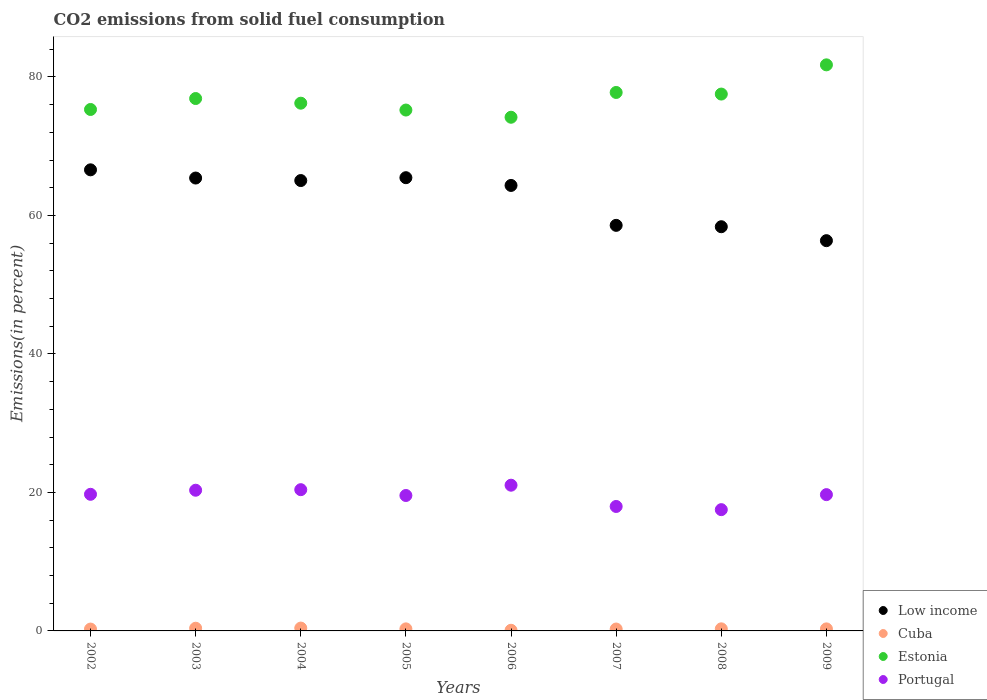Is the number of dotlines equal to the number of legend labels?
Your answer should be compact. Yes. What is the total CO2 emitted in Cuba in 2004?
Keep it short and to the point. 0.41. Across all years, what is the maximum total CO2 emitted in Cuba?
Your answer should be compact. 0.41. Across all years, what is the minimum total CO2 emitted in Cuba?
Provide a succinct answer. 0.09. What is the total total CO2 emitted in Low income in the graph?
Give a very brief answer. 500.1. What is the difference between the total CO2 emitted in Cuba in 2002 and that in 2007?
Your answer should be very brief. -0.01. What is the difference between the total CO2 emitted in Estonia in 2007 and the total CO2 emitted in Cuba in 2009?
Provide a succinct answer. 77.46. What is the average total CO2 emitted in Low income per year?
Your answer should be very brief. 62.51. In the year 2009, what is the difference between the total CO2 emitted in Low income and total CO2 emitted in Portugal?
Ensure brevity in your answer.  36.68. What is the ratio of the total CO2 emitted in Cuba in 2003 to that in 2009?
Your response must be concise. 1.32. What is the difference between the highest and the second highest total CO2 emitted in Estonia?
Your answer should be very brief. 3.99. What is the difference between the highest and the lowest total CO2 emitted in Cuba?
Keep it short and to the point. 0.32. In how many years, is the total CO2 emitted in Portugal greater than the average total CO2 emitted in Portugal taken over all years?
Your answer should be very brief. 6. Is the sum of the total CO2 emitted in Estonia in 2004 and 2008 greater than the maximum total CO2 emitted in Cuba across all years?
Give a very brief answer. Yes. Is it the case that in every year, the sum of the total CO2 emitted in Portugal and total CO2 emitted in Low income  is greater than the total CO2 emitted in Estonia?
Your response must be concise. No. How many years are there in the graph?
Your answer should be compact. 8. Are the values on the major ticks of Y-axis written in scientific E-notation?
Your answer should be compact. No. Does the graph contain grids?
Make the answer very short. No. Where does the legend appear in the graph?
Offer a very short reply. Bottom right. How many legend labels are there?
Provide a short and direct response. 4. What is the title of the graph?
Offer a terse response. CO2 emissions from solid fuel consumption. What is the label or title of the X-axis?
Your response must be concise. Years. What is the label or title of the Y-axis?
Provide a short and direct response. Emissions(in percent). What is the Emissions(in percent) in Low income in 2002?
Keep it short and to the point. 66.59. What is the Emissions(in percent) in Cuba in 2002?
Keep it short and to the point. 0.27. What is the Emissions(in percent) in Estonia in 2002?
Your answer should be compact. 75.3. What is the Emissions(in percent) of Portugal in 2002?
Give a very brief answer. 19.73. What is the Emissions(in percent) of Low income in 2003?
Offer a terse response. 65.4. What is the Emissions(in percent) of Cuba in 2003?
Give a very brief answer. 0.39. What is the Emissions(in percent) of Estonia in 2003?
Ensure brevity in your answer.  76.88. What is the Emissions(in percent) of Portugal in 2003?
Make the answer very short. 20.32. What is the Emissions(in percent) of Low income in 2004?
Ensure brevity in your answer.  65.04. What is the Emissions(in percent) of Cuba in 2004?
Your answer should be compact. 0.41. What is the Emissions(in percent) in Estonia in 2004?
Provide a succinct answer. 76.21. What is the Emissions(in percent) in Portugal in 2004?
Your response must be concise. 20.4. What is the Emissions(in percent) of Low income in 2005?
Offer a very short reply. 65.45. What is the Emissions(in percent) in Cuba in 2005?
Provide a short and direct response. 0.3. What is the Emissions(in percent) in Estonia in 2005?
Provide a succinct answer. 75.22. What is the Emissions(in percent) of Portugal in 2005?
Your response must be concise. 19.56. What is the Emissions(in percent) of Low income in 2006?
Provide a succinct answer. 64.33. What is the Emissions(in percent) of Cuba in 2006?
Give a very brief answer. 0.09. What is the Emissions(in percent) in Estonia in 2006?
Your answer should be compact. 74.18. What is the Emissions(in percent) of Portugal in 2006?
Give a very brief answer. 21.04. What is the Emissions(in percent) of Low income in 2007?
Provide a succinct answer. 58.57. What is the Emissions(in percent) in Cuba in 2007?
Offer a terse response. 0.27. What is the Emissions(in percent) of Estonia in 2007?
Your response must be concise. 77.76. What is the Emissions(in percent) of Portugal in 2007?
Your answer should be very brief. 17.97. What is the Emissions(in percent) of Low income in 2008?
Offer a terse response. 58.37. What is the Emissions(in percent) of Cuba in 2008?
Give a very brief answer. 0.3. What is the Emissions(in percent) of Estonia in 2008?
Provide a short and direct response. 77.53. What is the Emissions(in percent) in Portugal in 2008?
Your response must be concise. 17.51. What is the Emissions(in percent) in Low income in 2009?
Provide a short and direct response. 56.36. What is the Emissions(in percent) of Cuba in 2009?
Your response must be concise. 0.29. What is the Emissions(in percent) of Estonia in 2009?
Offer a terse response. 81.75. What is the Emissions(in percent) in Portugal in 2009?
Your response must be concise. 19.68. Across all years, what is the maximum Emissions(in percent) of Low income?
Offer a terse response. 66.59. Across all years, what is the maximum Emissions(in percent) of Cuba?
Make the answer very short. 0.41. Across all years, what is the maximum Emissions(in percent) in Estonia?
Your answer should be compact. 81.75. Across all years, what is the maximum Emissions(in percent) in Portugal?
Provide a succinct answer. 21.04. Across all years, what is the minimum Emissions(in percent) in Low income?
Ensure brevity in your answer.  56.36. Across all years, what is the minimum Emissions(in percent) of Cuba?
Provide a short and direct response. 0.09. Across all years, what is the minimum Emissions(in percent) of Estonia?
Your response must be concise. 74.18. Across all years, what is the minimum Emissions(in percent) of Portugal?
Provide a short and direct response. 17.51. What is the total Emissions(in percent) in Low income in the graph?
Provide a succinct answer. 500.1. What is the total Emissions(in percent) in Cuba in the graph?
Make the answer very short. 2.33. What is the total Emissions(in percent) of Estonia in the graph?
Provide a succinct answer. 614.82. What is the total Emissions(in percent) in Portugal in the graph?
Make the answer very short. 156.21. What is the difference between the Emissions(in percent) of Low income in 2002 and that in 2003?
Keep it short and to the point. 1.19. What is the difference between the Emissions(in percent) in Cuba in 2002 and that in 2003?
Your answer should be compact. -0.12. What is the difference between the Emissions(in percent) of Estonia in 2002 and that in 2003?
Offer a terse response. -1.58. What is the difference between the Emissions(in percent) of Portugal in 2002 and that in 2003?
Provide a succinct answer. -0.59. What is the difference between the Emissions(in percent) of Low income in 2002 and that in 2004?
Make the answer very short. 1.55. What is the difference between the Emissions(in percent) in Cuba in 2002 and that in 2004?
Ensure brevity in your answer.  -0.14. What is the difference between the Emissions(in percent) in Estonia in 2002 and that in 2004?
Offer a very short reply. -0.91. What is the difference between the Emissions(in percent) of Portugal in 2002 and that in 2004?
Offer a very short reply. -0.67. What is the difference between the Emissions(in percent) in Low income in 2002 and that in 2005?
Make the answer very short. 1.14. What is the difference between the Emissions(in percent) of Cuba in 2002 and that in 2005?
Make the answer very short. -0.03. What is the difference between the Emissions(in percent) of Estonia in 2002 and that in 2005?
Your response must be concise. 0.08. What is the difference between the Emissions(in percent) in Portugal in 2002 and that in 2005?
Ensure brevity in your answer.  0.17. What is the difference between the Emissions(in percent) in Low income in 2002 and that in 2006?
Ensure brevity in your answer.  2.25. What is the difference between the Emissions(in percent) of Cuba in 2002 and that in 2006?
Your answer should be compact. 0.17. What is the difference between the Emissions(in percent) in Estonia in 2002 and that in 2006?
Provide a short and direct response. 1.12. What is the difference between the Emissions(in percent) in Portugal in 2002 and that in 2006?
Ensure brevity in your answer.  -1.31. What is the difference between the Emissions(in percent) in Low income in 2002 and that in 2007?
Provide a succinct answer. 8.02. What is the difference between the Emissions(in percent) of Cuba in 2002 and that in 2007?
Give a very brief answer. -0.01. What is the difference between the Emissions(in percent) of Estonia in 2002 and that in 2007?
Your response must be concise. -2.46. What is the difference between the Emissions(in percent) in Portugal in 2002 and that in 2007?
Your answer should be very brief. 1.76. What is the difference between the Emissions(in percent) of Low income in 2002 and that in 2008?
Offer a terse response. 8.22. What is the difference between the Emissions(in percent) in Cuba in 2002 and that in 2008?
Keep it short and to the point. -0.03. What is the difference between the Emissions(in percent) in Estonia in 2002 and that in 2008?
Your response must be concise. -2.23. What is the difference between the Emissions(in percent) of Portugal in 2002 and that in 2008?
Give a very brief answer. 2.22. What is the difference between the Emissions(in percent) in Low income in 2002 and that in 2009?
Ensure brevity in your answer.  10.23. What is the difference between the Emissions(in percent) of Cuba in 2002 and that in 2009?
Your answer should be compact. -0.03. What is the difference between the Emissions(in percent) of Estonia in 2002 and that in 2009?
Provide a succinct answer. -6.45. What is the difference between the Emissions(in percent) in Portugal in 2002 and that in 2009?
Offer a terse response. 0.05. What is the difference between the Emissions(in percent) of Low income in 2003 and that in 2004?
Provide a succinct answer. 0.36. What is the difference between the Emissions(in percent) of Cuba in 2003 and that in 2004?
Make the answer very short. -0.02. What is the difference between the Emissions(in percent) of Estonia in 2003 and that in 2004?
Your response must be concise. 0.67. What is the difference between the Emissions(in percent) of Portugal in 2003 and that in 2004?
Ensure brevity in your answer.  -0.08. What is the difference between the Emissions(in percent) in Low income in 2003 and that in 2005?
Your answer should be compact. -0.05. What is the difference between the Emissions(in percent) in Cuba in 2003 and that in 2005?
Ensure brevity in your answer.  0.09. What is the difference between the Emissions(in percent) of Estonia in 2003 and that in 2005?
Provide a succinct answer. 1.66. What is the difference between the Emissions(in percent) in Portugal in 2003 and that in 2005?
Ensure brevity in your answer.  0.76. What is the difference between the Emissions(in percent) in Low income in 2003 and that in 2006?
Offer a very short reply. 1.07. What is the difference between the Emissions(in percent) in Cuba in 2003 and that in 2006?
Offer a terse response. 0.29. What is the difference between the Emissions(in percent) of Estonia in 2003 and that in 2006?
Ensure brevity in your answer.  2.7. What is the difference between the Emissions(in percent) in Portugal in 2003 and that in 2006?
Your response must be concise. -0.73. What is the difference between the Emissions(in percent) in Low income in 2003 and that in 2007?
Your answer should be very brief. 6.83. What is the difference between the Emissions(in percent) of Cuba in 2003 and that in 2007?
Give a very brief answer. 0.11. What is the difference between the Emissions(in percent) in Estonia in 2003 and that in 2007?
Ensure brevity in your answer.  -0.88. What is the difference between the Emissions(in percent) of Portugal in 2003 and that in 2007?
Make the answer very short. 2.35. What is the difference between the Emissions(in percent) of Low income in 2003 and that in 2008?
Keep it short and to the point. 7.03. What is the difference between the Emissions(in percent) of Cuba in 2003 and that in 2008?
Your answer should be very brief. 0.09. What is the difference between the Emissions(in percent) of Estonia in 2003 and that in 2008?
Your response must be concise. -0.64. What is the difference between the Emissions(in percent) in Portugal in 2003 and that in 2008?
Your answer should be compact. 2.8. What is the difference between the Emissions(in percent) in Low income in 2003 and that in 2009?
Your answer should be compact. 9.04. What is the difference between the Emissions(in percent) of Cuba in 2003 and that in 2009?
Your answer should be compact. 0.09. What is the difference between the Emissions(in percent) in Estonia in 2003 and that in 2009?
Provide a succinct answer. -4.86. What is the difference between the Emissions(in percent) in Portugal in 2003 and that in 2009?
Keep it short and to the point. 0.64. What is the difference between the Emissions(in percent) of Low income in 2004 and that in 2005?
Your answer should be compact. -0.41. What is the difference between the Emissions(in percent) of Cuba in 2004 and that in 2005?
Provide a short and direct response. 0.11. What is the difference between the Emissions(in percent) in Estonia in 2004 and that in 2005?
Offer a terse response. 0.99. What is the difference between the Emissions(in percent) in Portugal in 2004 and that in 2005?
Provide a succinct answer. 0.84. What is the difference between the Emissions(in percent) in Low income in 2004 and that in 2006?
Your answer should be very brief. 0.71. What is the difference between the Emissions(in percent) of Cuba in 2004 and that in 2006?
Your answer should be compact. 0.32. What is the difference between the Emissions(in percent) of Estonia in 2004 and that in 2006?
Your response must be concise. 2.03. What is the difference between the Emissions(in percent) of Portugal in 2004 and that in 2006?
Your answer should be very brief. -0.65. What is the difference between the Emissions(in percent) in Low income in 2004 and that in 2007?
Your answer should be compact. 6.47. What is the difference between the Emissions(in percent) of Cuba in 2004 and that in 2007?
Provide a short and direct response. 0.14. What is the difference between the Emissions(in percent) in Estonia in 2004 and that in 2007?
Keep it short and to the point. -1.55. What is the difference between the Emissions(in percent) of Portugal in 2004 and that in 2007?
Keep it short and to the point. 2.42. What is the difference between the Emissions(in percent) in Low income in 2004 and that in 2008?
Provide a short and direct response. 6.67. What is the difference between the Emissions(in percent) in Cuba in 2004 and that in 2008?
Provide a succinct answer. 0.11. What is the difference between the Emissions(in percent) in Estonia in 2004 and that in 2008?
Make the answer very short. -1.32. What is the difference between the Emissions(in percent) in Portugal in 2004 and that in 2008?
Make the answer very short. 2.88. What is the difference between the Emissions(in percent) of Low income in 2004 and that in 2009?
Provide a succinct answer. 8.68. What is the difference between the Emissions(in percent) of Cuba in 2004 and that in 2009?
Make the answer very short. 0.12. What is the difference between the Emissions(in percent) of Estonia in 2004 and that in 2009?
Keep it short and to the point. -5.54. What is the difference between the Emissions(in percent) in Portugal in 2004 and that in 2009?
Ensure brevity in your answer.  0.72. What is the difference between the Emissions(in percent) of Low income in 2005 and that in 2006?
Your response must be concise. 1.12. What is the difference between the Emissions(in percent) of Cuba in 2005 and that in 2006?
Offer a very short reply. 0.2. What is the difference between the Emissions(in percent) of Estonia in 2005 and that in 2006?
Offer a very short reply. 1.04. What is the difference between the Emissions(in percent) in Portugal in 2005 and that in 2006?
Give a very brief answer. -1.49. What is the difference between the Emissions(in percent) in Low income in 2005 and that in 2007?
Your response must be concise. 6.88. What is the difference between the Emissions(in percent) in Cuba in 2005 and that in 2007?
Provide a succinct answer. 0.02. What is the difference between the Emissions(in percent) of Estonia in 2005 and that in 2007?
Provide a succinct answer. -2.54. What is the difference between the Emissions(in percent) of Portugal in 2005 and that in 2007?
Make the answer very short. 1.58. What is the difference between the Emissions(in percent) in Low income in 2005 and that in 2008?
Keep it short and to the point. 7.08. What is the difference between the Emissions(in percent) of Cuba in 2005 and that in 2008?
Keep it short and to the point. -0.01. What is the difference between the Emissions(in percent) of Estonia in 2005 and that in 2008?
Make the answer very short. -2.31. What is the difference between the Emissions(in percent) in Portugal in 2005 and that in 2008?
Your response must be concise. 2.04. What is the difference between the Emissions(in percent) in Low income in 2005 and that in 2009?
Ensure brevity in your answer.  9.09. What is the difference between the Emissions(in percent) in Cuba in 2005 and that in 2009?
Offer a terse response. 0. What is the difference between the Emissions(in percent) in Estonia in 2005 and that in 2009?
Make the answer very short. -6.53. What is the difference between the Emissions(in percent) of Portugal in 2005 and that in 2009?
Ensure brevity in your answer.  -0.12. What is the difference between the Emissions(in percent) of Low income in 2006 and that in 2007?
Make the answer very short. 5.76. What is the difference between the Emissions(in percent) of Cuba in 2006 and that in 2007?
Keep it short and to the point. -0.18. What is the difference between the Emissions(in percent) in Estonia in 2006 and that in 2007?
Ensure brevity in your answer.  -3.58. What is the difference between the Emissions(in percent) in Portugal in 2006 and that in 2007?
Ensure brevity in your answer.  3.07. What is the difference between the Emissions(in percent) of Low income in 2006 and that in 2008?
Your response must be concise. 5.96. What is the difference between the Emissions(in percent) in Cuba in 2006 and that in 2008?
Ensure brevity in your answer.  -0.21. What is the difference between the Emissions(in percent) of Estonia in 2006 and that in 2008?
Offer a terse response. -3.35. What is the difference between the Emissions(in percent) of Portugal in 2006 and that in 2008?
Give a very brief answer. 3.53. What is the difference between the Emissions(in percent) in Low income in 2006 and that in 2009?
Offer a terse response. 7.97. What is the difference between the Emissions(in percent) of Cuba in 2006 and that in 2009?
Make the answer very short. -0.2. What is the difference between the Emissions(in percent) in Estonia in 2006 and that in 2009?
Keep it short and to the point. -7.57. What is the difference between the Emissions(in percent) in Portugal in 2006 and that in 2009?
Keep it short and to the point. 1.36. What is the difference between the Emissions(in percent) of Low income in 2007 and that in 2008?
Keep it short and to the point. 0.2. What is the difference between the Emissions(in percent) in Cuba in 2007 and that in 2008?
Your response must be concise. -0.03. What is the difference between the Emissions(in percent) in Estonia in 2007 and that in 2008?
Your response must be concise. 0.23. What is the difference between the Emissions(in percent) of Portugal in 2007 and that in 2008?
Keep it short and to the point. 0.46. What is the difference between the Emissions(in percent) in Low income in 2007 and that in 2009?
Ensure brevity in your answer.  2.21. What is the difference between the Emissions(in percent) of Cuba in 2007 and that in 2009?
Your response must be concise. -0.02. What is the difference between the Emissions(in percent) of Estonia in 2007 and that in 2009?
Offer a terse response. -3.99. What is the difference between the Emissions(in percent) of Portugal in 2007 and that in 2009?
Make the answer very short. -1.71. What is the difference between the Emissions(in percent) of Low income in 2008 and that in 2009?
Provide a short and direct response. 2.01. What is the difference between the Emissions(in percent) of Cuba in 2008 and that in 2009?
Provide a succinct answer. 0.01. What is the difference between the Emissions(in percent) in Estonia in 2008 and that in 2009?
Provide a short and direct response. -4.22. What is the difference between the Emissions(in percent) in Portugal in 2008 and that in 2009?
Give a very brief answer. -2.17. What is the difference between the Emissions(in percent) of Low income in 2002 and the Emissions(in percent) of Cuba in 2003?
Give a very brief answer. 66.2. What is the difference between the Emissions(in percent) in Low income in 2002 and the Emissions(in percent) in Estonia in 2003?
Provide a short and direct response. -10.3. What is the difference between the Emissions(in percent) of Low income in 2002 and the Emissions(in percent) of Portugal in 2003?
Provide a short and direct response. 46.27. What is the difference between the Emissions(in percent) of Cuba in 2002 and the Emissions(in percent) of Estonia in 2003?
Your response must be concise. -76.61. What is the difference between the Emissions(in percent) in Cuba in 2002 and the Emissions(in percent) in Portugal in 2003?
Give a very brief answer. -20.05. What is the difference between the Emissions(in percent) in Estonia in 2002 and the Emissions(in percent) in Portugal in 2003?
Give a very brief answer. 54.98. What is the difference between the Emissions(in percent) in Low income in 2002 and the Emissions(in percent) in Cuba in 2004?
Provide a succinct answer. 66.17. What is the difference between the Emissions(in percent) in Low income in 2002 and the Emissions(in percent) in Estonia in 2004?
Ensure brevity in your answer.  -9.62. What is the difference between the Emissions(in percent) of Low income in 2002 and the Emissions(in percent) of Portugal in 2004?
Your answer should be compact. 46.19. What is the difference between the Emissions(in percent) of Cuba in 2002 and the Emissions(in percent) of Estonia in 2004?
Ensure brevity in your answer.  -75.94. What is the difference between the Emissions(in percent) in Cuba in 2002 and the Emissions(in percent) in Portugal in 2004?
Offer a terse response. -20.13. What is the difference between the Emissions(in percent) of Estonia in 2002 and the Emissions(in percent) of Portugal in 2004?
Your response must be concise. 54.9. What is the difference between the Emissions(in percent) in Low income in 2002 and the Emissions(in percent) in Cuba in 2005?
Your answer should be compact. 66.29. What is the difference between the Emissions(in percent) in Low income in 2002 and the Emissions(in percent) in Estonia in 2005?
Ensure brevity in your answer.  -8.63. What is the difference between the Emissions(in percent) of Low income in 2002 and the Emissions(in percent) of Portugal in 2005?
Make the answer very short. 47.03. What is the difference between the Emissions(in percent) of Cuba in 2002 and the Emissions(in percent) of Estonia in 2005?
Your answer should be compact. -74.95. What is the difference between the Emissions(in percent) of Cuba in 2002 and the Emissions(in percent) of Portugal in 2005?
Make the answer very short. -19.29. What is the difference between the Emissions(in percent) in Estonia in 2002 and the Emissions(in percent) in Portugal in 2005?
Provide a short and direct response. 55.74. What is the difference between the Emissions(in percent) of Low income in 2002 and the Emissions(in percent) of Cuba in 2006?
Offer a very short reply. 66.49. What is the difference between the Emissions(in percent) in Low income in 2002 and the Emissions(in percent) in Estonia in 2006?
Your answer should be very brief. -7.59. What is the difference between the Emissions(in percent) of Low income in 2002 and the Emissions(in percent) of Portugal in 2006?
Offer a very short reply. 45.54. What is the difference between the Emissions(in percent) of Cuba in 2002 and the Emissions(in percent) of Estonia in 2006?
Offer a terse response. -73.91. What is the difference between the Emissions(in percent) in Cuba in 2002 and the Emissions(in percent) in Portugal in 2006?
Ensure brevity in your answer.  -20.78. What is the difference between the Emissions(in percent) of Estonia in 2002 and the Emissions(in percent) of Portugal in 2006?
Your response must be concise. 54.26. What is the difference between the Emissions(in percent) of Low income in 2002 and the Emissions(in percent) of Cuba in 2007?
Provide a short and direct response. 66.31. What is the difference between the Emissions(in percent) in Low income in 2002 and the Emissions(in percent) in Estonia in 2007?
Keep it short and to the point. -11.17. What is the difference between the Emissions(in percent) of Low income in 2002 and the Emissions(in percent) of Portugal in 2007?
Your answer should be very brief. 48.61. What is the difference between the Emissions(in percent) of Cuba in 2002 and the Emissions(in percent) of Estonia in 2007?
Ensure brevity in your answer.  -77.49. What is the difference between the Emissions(in percent) of Cuba in 2002 and the Emissions(in percent) of Portugal in 2007?
Keep it short and to the point. -17.7. What is the difference between the Emissions(in percent) in Estonia in 2002 and the Emissions(in percent) in Portugal in 2007?
Provide a short and direct response. 57.33. What is the difference between the Emissions(in percent) of Low income in 2002 and the Emissions(in percent) of Cuba in 2008?
Give a very brief answer. 66.28. What is the difference between the Emissions(in percent) of Low income in 2002 and the Emissions(in percent) of Estonia in 2008?
Your answer should be compact. -10.94. What is the difference between the Emissions(in percent) of Low income in 2002 and the Emissions(in percent) of Portugal in 2008?
Give a very brief answer. 49.07. What is the difference between the Emissions(in percent) of Cuba in 2002 and the Emissions(in percent) of Estonia in 2008?
Provide a short and direct response. -77.26. What is the difference between the Emissions(in percent) in Cuba in 2002 and the Emissions(in percent) in Portugal in 2008?
Your answer should be very brief. -17.25. What is the difference between the Emissions(in percent) in Estonia in 2002 and the Emissions(in percent) in Portugal in 2008?
Provide a succinct answer. 57.79. What is the difference between the Emissions(in percent) of Low income in 2002 and the Emissions(in percent) of Cuba in 2009?
Your answer should be very brief. 66.29. What is the difference between the Emissions(in percent) of Low income in 2002 and the Emissions(in percent) of Estonia in 2009?
Make the answer very short. -15.16. What is the difference between the Emissions(in percent) in Low income in 2002 and the Emissions(in percent) in Portugal in 2009?
Give a very brief answer. 46.9. What is the difference between the Emissions(in percent) of Cuba in 2002 and the Emissions(in percent) of Estonia in 2009?
Keep it short and to the point. -81.48. What is the difference between the Emissions(in percent) of Cuba in 2002 and the Emissions(in percent) of Portugal in 2009?
Keep it short and to the point. -19.41. What is the difference between the Emissions(in percent) in Estonia in 2002 and the Emissions(in percent) in Portugal in 2009?
Your answer should be compact. 55.62. What is the difference between the Emissions(in percent) in Low income in 2003 and the Emissions(in percent) in Cuba in 2004?
Give a very brief answer. 64.99. What is the difference between the Emissions(in percent) of Low income in 2003 and the Emissions(in percent) of Estonia in 2004?
Make the answer very short. -10.81. What is the difference between the Emissions(in percent) of Low income in 2003 and the Emissions(in percent) of Portugal in 2004?
Your response must be concise. 45. What is the difference between the Emissions(in percent) of Cuba in 2003 and the Emissions(in percent) of Estonia in 2004?
Your response must be concise. -75.82. What is the difference between the Emissions(in percent) in Cuba in 2003 and the Emissions(in percent) in Portugal in 2004?
Your response must be concise. -20.01. What is the difference between the Emissions(in percent) of Estonia in 2003 and the Emissions(in percent) of Portugal in 2004?
Provide a short and direct response. 56.48. What is the difference between the Emissions(in percent) of Low income in 2003 and the Emissions(in percent) of Cuba in 2005?
Keep it short and to the point. 65.1. What is the difference between the Emissions(in percent) of Low income in 2003 and the Emissions(in percent) of Estonia in 2005?
Provide a short and direct response. -9.82. What is the difference between the Emissions(in percent) of Low income in 2003 and the Emissions(in percent) of Portugal in 2005?
Ensure brevity in your answer.  45.84. What is the difference between the Emissions(in percent) in Cuba in 2003 and the Emissions(in percent) in Estonia in 2005?
Provide a succinct answer. -74.83. What is the difference between the Emissions(in percent) of Cuba in 2003 and the Emissions(in percent) of Portugal in 2005?
Offer a very short reply. -19.17. What is the difference between the Emissions(in percent) of Estonia in 2003 and the Emissions(in percent) of Portugal in 2005?
Your answer should be very brief. 57.33. What is the difference between the Emissions(in percent) in Low income in 2003 and the Emissions(in percent) in Cuba in 2006?
Provide a succinct answer. 65.31. What is the difference between the Emissions(in percent) in Low income in 2003 and the Emissions(in percent) in Estonia in 2006?
Make the answer very short. -8.78. What is the difference between the Emissions(in percent) of Low income in 2003 and the Emissions(in percent) of Portugal in 2006?
Make the answer very short. 44.36. What is the difference between the Emissions(in percent) of Cuba in 2003 and the Emissions(in percent) of Estonia in 2006?
Provide a succinct answer. -73.79. What is the difference between the Emissions(in percent) in Cuba in 2003 and the Emissions(in percent) in Portugal in 2006?
Give a very brief answer. -20.66. What is the difference between the Emissions(in percent) in Estonia in 2003 and the Emissions(in percent) in Portugal in 2006?
Ensure brevity in your answer.  55.84. What is the difference between the Emissions(in percent) in Low income in 2003 and the Emissions(in percent) in Cuba in 2007?
Give a very brief answer. 65.13. What is the difference between the Emissions(in percent) of Low income in 2003 and the Emissions(in percent) of Estonia in 2007?
Provide a short and direct response. -12.36. What is the difference between the Emissions(in percent) of Low income in 2003 and the Emissions(in percent) of Portugal in 2007?
Make the answer very short. 47.43. What is the difference between the Emissions(in percent) in Cuba in 2003 and the Emissions(in percent) in Estonia in 2007?
Provide a short and direct response. -77.37. What is the difference between the Emissions(in percent) in Cuba in 2003 and the Emissions(in percent) in Portugal in 2007?
Provide a succinct answer. -17.58. What is the difference between the Emissions(in percent) of Estonia in 2003 and the Emissions(in percent) of Portugal in 2007?
Keep it short and to the point. 58.91. What is the difference between the Emissions(in percent) in Low income in 2003 and the Emissions(in percent) in Cuba in 2008?
Give a very brief answer. 65.1. What is the difference between the Emissions(in percent) in Low income in 2003 and the Emissions(in percent) in Estonia in 2008?
Ensure brevity in your answer.  -12.13. What is the difference between the Emissions(in percent) in Low income in 2003 and the Emissions(in percent) in Portugal in 2008?
Keep it short and to the point. 47.89. What is the difference between the Emissions(in percent) of Cuba in 2003 and the Emissions(in percent) of Estonia in 2008?
Offer a terse response. -77.14. What is the difference between the Emissions(in percent) of Cuba in 2003 and the Emissions(in percent) of Portugal in 2008?
Your response must be concise. -17.12. What is the difference between the Emissions(in percent) in Estonia in 2003 and the Emissions(in percent) in Portugal in 2008?
Make the answer very short. 59.37. What is the difference between the Emissions(in percent) of Low income in 2003 and the Emissions(in percent) of Cuba in 2009?
Offer a terse response. 65.11. What is the difference between the Emissions(in percent) of Low income in 2003 and the Emissions(in percent) of Estonia in 2009?
Keep it short and to the point. -16.35. What is the difference between the Emissions(in percent) of Low income in 2003 and the Emissions(in percent) of Portugal in 2009?
Your answer should be compact. 45.72. What is the difference between the Emissions(in percent) of Cuba in 2003 and the Emissions(in percent) of Estonia in 2009?
Offer a terse response. -81.36. What is the difference between the Emissions(in percent) of Cuba in 2003 and the Emissions(in percent) of Portugal in 2009?
Your answer should be compact. -19.29. What is the difference between the Emissions(in percent) in Estonia in 2003 and the Emissions(in percent) in Portugal in 2009?
Your answer should be compact. 57.2. What is the difference between the Emissions(in percent) of Low income in 2004 and the Emissions(in percent) of Cuba in 2005?
Provide a short and direct response. 64.74. What is the difference between the Emissions(in percent) in Low income in 2004 and the Emissions(in percent) in Estonia in 2005?
Your answer should be very brief. -10.18. What is the difference between the Emissions(in percent) in Low income in 2004 and the Emissions(in percent) in Portugal in 2005?
Offer a terse response. 45.48. What is the difference between the Emissions(in percent) in Cuba in 2004 and the Emissions(in percent) in Estonia in 2005?
Ensure brevity in your answer.  -74.81. What is the difference between the Emissions(in percent) of Cuba in 2004 and the Emissions(in percent) of Portugal in 2005?
Offer a very short reply. -19.15. What is the difference between the Emissions(in percent) in Estonia in 2004 and the Emissions(in percent) in Portugal in 2005?
Give a very brief answer. 56.65. What is the difference between the Emissions(in percent) of Low income in 2004 and the Emissions(in percent) of Cuba in 2006?
Offer a very short reply. 64.94. What is the difference between the Emissions(in percent) of Low income in 2004 and the Emissions(in percent) of Estonia in 2006?
Ensure brevity in your answer.  -9.14. What is the difference between the Emissions(in percent) in Low income in 2004 and the Emissions(in percent) in Portugal in 2006?
Offer a very short reply. 43.99. What is the difference between the Emissions(in percent) of Cuba in 2004 and the Emissions(in percent) of Estonia in 2006?
Give a very brief answer. -73.77. What is the difference between the Emissions(in percent) in Cuba in 2004 and the Emissions(in percent) in Portugal in 2006?
Keep it short and to the point. -20.63. What is the difference between the Emissions(in percent) in Estonia in 2004 and the Emissions(in percent) in Portugal in 2006?
Your response must be concise. 55.17. What is the difference between the Emissions(in percent) of Low income in 2004 and the Emissions(in percent) of Cuba in 2007?
Your answer should be compact. 64.76. What is the difference between the Emissions(in percent) in Low income in 2004 and the Emissions(in percent) in Estonia in 2007?
Ensure brevity in your answer.  -12.72. What is the difference between the Emissions(in percent) of Low income in 2004 and the Emissions(in percent) of Portugal in 2007?
Your response must be concise. 47.07. What is the difference between the Emissions(in percent) in Cuba in 2004 and the Emissions(in percent) in Estonia in 2007?
Your response must be concise. -77.35. What is the difference between the Emissions(in percent) of Cuba in 2004 and the Emissions(in percent) of Portugal in 2007?
Make the answer very short. -17.56. What is the difference between the Emissions(in percent) of Estonia in 2004 and the Emissions(in percent) of Portugal in 2007?
Your answer should be very brief. 58.24. What is the difference between the Emissions(in percent) in Low income in 2004 and the Emissions(in percent) in Cuba in 2008?
Provide a short and direct response. 64.74. What is the difference between the Emissions(in percent) of Low income in 2004 and the Emissions(in percent) of Estonia in 2008?
Provide a succinct answer. -12.49. What is the difference between the Emissions(in percent) in Low income in 2004 and the Emissions(in percent) in Portugal in 2008?
Your response must be concise. 47.52. What is the difference between the Emissions(in percent) of Cuba in 2004 and the Emissions(in percent) of Estonia in 2008?
Your answer should be very brief. -77.12. What is the difference between the Emissions(in percent) in Cuba in 2004 and the Emissions(in percent) in Portugal in 2008?
Keep it short and to the point. -17.1. What is the difference between the Emissions(in percent) of Estonia in 2004 and the Emissions(in percent) of Portugal in 2008?
Offer a terse response. 58.7. What is the difference between the Emissions(in percent) in Low income in 2004 and the Emissions(in percent) in Cuba in 2009?
Your response must be concise. 64.74. What is the difference between the Emissions(in percent) of Low income in 2004 and the Emissions(in percent) of Estonia in 2009?
Offer a very short reply. -16.71. What is the difference between the Emissions(in percent) of Low income in 2004 and the Emissions(in percent) of Portugal in 2009?
Make the answer very short. 45.36. What is the difference between the Emissions(in percent) of Cuba in 2004 and the Emissions(in percent) of Estonia in 2009?
Provide a succinct answer. -81.34. What is the difference between the Emissions(in percent) in Cuba in 2004 and the Emissions(in percent) in Portugal in 2009?
Your response must be concise. -19.27. What is the difference between the Emissions(in percent) of Estonia in 2004 and the Emissions(in percent) of Portugal in 2009?
Your answer should be very brief. 56.53. What is the difference between the Emissions(in percent) in Low income in 2005 and the Emissions(in percent) in Cuba in 2006?
Your answer should be compact. 65.36. What is the difference between the Emissions(in percent) of Low income in 2005 and the Emissions(in percent) of Estonia in 2006?
Keep it short and to the point. -8.73. What is the difference between the Emissions(in percent) in Low income in 2005 and the Emissions(in percent) in Portugal in 2006?
Your answer should be very brief. 44.41. What is the difference between the Emissions(in percent) in Cuba in 2005 and the Emissions(in percent) in Estonia in 2006?
Give a very brief answer. -73.88. What is the difference between the Emissions(in percent) in Cuba in 2005 and the Emissions(in percent) in Portugal in 2006?
Offer a terse response. -20.75. What is the difference between the Emissions(in percent) in Estonia in 2005 and the Emissions(in percent) in Portugal in 2006?
Offer a very short reply. 54.17. What is the difference between the Emissions(in percent) in Low income in 2005 and the Emissions(in percent) in Cuba in 2007?
Keep it short and to the point. 65.18. What is the difference between the Emissions(in percent) in Low income in 2005 and the Emissions(in percent) in Estonia in 2007?
Your answer should be very brief. -12.31. What is the difference between the Emissions(in percent) in Low income in 2005 and the Emissions(in percent) in Portugal in 2007?
Give a very brief answer. 47.48. What is the difference between the Emissions(in percent) in Cuba in 2005 and the Emissions(in percent) in Estonia in 2007?
Keep it short and to the point. -77.46. What is the difference between the Emissions(in percent) of Cuba in 2005 and the Emissions(in percent) of Portugal in 2007?
Your answer should be very brief. -17.68. What is the difference between the Emissions(in percent) in Estonia in 2005 and the Emissions(in percent) in Portugal in 2007?
Provide a short and direct response. 57.25. What is the difference between the Emissions(in percent) in Low income in 2005 and the Emissions(in percent) in Cuba in 2008?
Your answer should be compact. 65.15. What is the difference between the Emissions(in percent) in Low income in 2005 and the Emissions(in percent) in Estonia in 2008?
Offer a very short reply. -12.08. What is the difference between the Emissions(in percent) of Low income in 2005 and the Emissions(in percent) of Portugal in 2008?
Offer a very short reply. 47.94. What is the difference between the Emissions(in percent) in Cuba in 2005 and the Emissions(in percent) in Estonia in 2008?
Your response must be concise. -77.23. What is the difference between the Emissions(in percent) of Cuba in 2005 and the Emissions(in percent) of Portugal in 2008?
Your response must be concise. -17.22. What is the difference between the Emissions(in percent) of Estonia in 2005 and the Emissions(in percent) of Portugal in 2008?
Provide a succinct answer. 57.71. What is the difference between the Emissions(in percent) in Low income in 2005 and the Emissions(in percent) in Cuba in 2009?
Your answer should be very brief. 65.16. What is the difference between the Emissions(in percent) of Low income in 2005 and the Emissions(in percent) of Estonia in 2009?
Make the answer very short. -16.3. What is the difference between the Emissions(in percent) of Low income in 2005 and the Emissions(in percent) of Portugal in 2009?
Make the answer very short. 45.77. What is the difference between the Emissions(in percent) of Cuba in 2005 and the Emissions(in percent) of Estonia in 2009?
Your response must be concise. -81.45. What is the difference between the Emissions(in percent) of Cuba in 2005 and the Emissions(in percent) of Portugal in 2009?
Your answer should be compact. -19.39. What is the difference between the Emissions(in percent) in Estonia in 2005 and the Emissions(in percent) in Portugal in 2009?
Your answer should be compact. 55.54. What is the difference between the Emissions(in percent) of Low income in 2006 and the Emissions(in percent) of Cuba in 2007?
Give a very brief answer. 64.06. What is the difference between the Emissions(in percent) of Low income in 2006 and the Emissions(in percent) of Estonia in 2007?
Offer a very short reply. -13.43. What is the difference between the Emissions(in percent) in Low income in 2006 and the Emissions(in percent) in Portugal in 2007?
Offer a terse response. 46.36. What is the difference between the Emissions(in percent) of Cuba in 2006 and the Emissions(in percent) of Estonia in 2007?
Your answer should be very brief. -77.66. What is the difference between the Emissions(in percent) in Cuba in 2006 and the Emissions(in percent) in Portugal in 2007?
Your response must be concise. -17.88. What is the difference between the Emissions(in percent) in Estonia in 2006 and the Emissions(in percent) in Portugal in 2007?
Your response must be concise. 56.21. What is the difference between the Emissions(in percent) of Low income in 2006 and the Emissions(in percent) of Cuba in 2008?
Your answer should be compact. 64.03. What is the difference between the Emissions(in percent) in Low income in 2006 and the Emissions(in percent) in Estonia in 2008?
Your response must be concise. -13.19. What is the difference between the Emissions(in percent) in Low income in 2006 and the Emissions(in percent) in Portugal in 2008?
Offer a terse response. 46.82. What is the difference between the Emissions(in percent) in Cuba in 2006 and the Emissions(in percent) in Estonia in 2008?
Ensure brevity in your answer.  -77.43. What is the difference between the Emissions(in percent) of Cuba in 2006 and the Emissions(in percent) of Portugal in 2008?
Give a very brief answer. -17.42. What is the difference between the Emissions(in percent) in Estonia in 2006 and the Emissions(in percent) in Portugal in 2008?
Offer a terse response. 56.67. What is the difference between the Emissions(in percent) in Low income in 2006 and the Emissions(in percent) in Cuba in 2009?
Make the answer very short. 64.04. What is the difference between the Emissions(in percent) in Low income in 2006 and the Emissions(in percent) in Estonia in 2009?
Give a very brief answer. -17.41. What is the difference between the Emissions(in percent) in Low income in 2006 and the Emissions(in percent) in Portugal in 2009?
Ensure brevity in your answer.  44.65. What is the difference between the Emissions(in percent) of Cuba in 2006 and the Emissions(in percent) of Estonia in 2009?
Your answer should be very brief. -81.65. What is the difference between the Emissions(in percent) in Cuba in 2006 and the Emissions(in percent) in Portugal in 2009?
Keep it short and to the point. -19.59. What is the difference between the Emissions(in percent) of Estonia in 2006 and the Emissions(in percent) of Portugal in 2009?
Make the answer very short. 54.5. What is the difference between the Emissions(in percent) of Low income in 2007 and the Emissions(in percent) of Cuba in 2008?
Offer a terse response. 58.27. What is the difference between the Emissions(in percent) in Low income in 2007 and the Emissions(in percent) in Estonia in 2008?
Offer a very short reply. -18.96. What is the difference between the Emissions(in percent) in Low income in 2007 and the Emissions(in percent) in Portugal in 2008?
Make the answer very short. 41.06. What is the difference between the Emissions(in percent) in Cuba in 2007 and the Emissions(in percent) in Estonia in 2008?
Make the answer very short. -77.25. What is the difference between the Emissions(in percent) in Cuba in 2007 and the Emissions(in percent) in Portugal in 2008?
Provide a succinct answer. -17.24. What is the difference between the Emissions(in percent) of Estonia in 2007 and the Emissions(in percent) of Portugal in 2008?
Ensure brevity in your answer.  60.25. What is the difference between the Emissions(in percent) in Low income in 2007 and the Emissions(in percent) in Cuba in 2009?
Provide a succinct answer. 58.27. What is the difference between the Emissions(in percent) in Low income in 2007 and the Emissions(in percent) in Estonia in 2009?
Your answer should be compact. -23.18. What is the difference between the Emissions(in percent) in Low income in 2007 and the Emissions(in percent) in Portugal in 2009?
Ensure brevity in your answer.  38.89. What is the difference between the Emissions(in percent) of Cuba in 2007 and the Emissions(in percent) of Estonia in 2009?
Your answer should be very brief. -81.47. What is the difference between the Emissions(in percent) of Cuba in 2007 and the Emissions(in percent) of Portugal in 2009?
Provide a short and direct response. -19.41. What is the difference between the Emissions(in percent) of Estonia in 2007 and the Emissions(in percent) of Portugal in 2009?
Offer a terse response. 58.08. What is the difference between the Emissions(in percent) in Low income in 2008 and the Emissions(in percent) in Cuba in 2009?
Ensure brevity in your answer.  58.07. What is the difference between the Emissions(in percent) in Low income in 2008 and the Emissions(in percent) in Estonia in 2009?
Your answer should be compact. -23.38. What is the difference between the Emissions(in percent) in Low income in 2008 and the Emissions(in percent) in Portugal in 2009?
Make the answer very short. 38.69. What is the difference between the Emissions(in percent) of Cuba in 2008 and the Emissions(in percent) of Estonia in 2009?
Offer a terse response. -81.44. What is the difference between the Emissions(in percent) in Cuba in 2008 and the Emissions(in percent) in Portugal in 2009?
Your answer should be compact. -19.38. What is the difference between the Emissions(in percent) in Estonia in 2008 and the Emissions(in percent) in Portugal in 2009?
Provide a short and direct response. 57.84. What is the average Emissions(in percent) in Low income per year?
Your response must be concise. 62.51. What is the average Emissions(in percent) in Cuba per year?
Give a very brief answer. 0.29. What is the average Emissions(in percent) in Estonia per year?
Provide a succinct answer. 76.85. What is the average Emissions(in percent) of Portugal per year?
Offer a terse response. 19.53. In the year 2002, what is the difference between the Emissions(in percent) in Low income and Emissions(in percent) in Cuba?
Offer a very short reply. 66.32. In the year 2002, what is the difference between the Emissions(in percent) in Low income and Emissions(in percent) in Estonia?
Your answer should be very brief. -8.72. In the year 2002, what is the difference between the Emissions(in percent) of Low income and Emissions(in percent) of Portugal?
Your response must be concise. 46.86. In the year 2002, what is the difference between the Emissions(in percent) in Cuba and Emissions(in percent) in Estonia?
Make the answer very short. -75.03. In the year 2002, what is the difference between the Emissions(in percent) in Cuba and Emissions(in percent) in Portugal?
Give a very brief answer. -19.46. In the year 2002, what is the difference between the Emissions(in percent) in Estonia and Emissions(in percent) in Portugal?
Provide a short and direct response. 55.57. In the year 2003, what is the difference between the Emissions(in percent) in Low income and Emissions(in percent) in Cuba?
Provide a short and direct response. 65.01. In the year 2003, what is the difference between the Emissions(in percent) of Low income and Emissions(in percent) of Estonia?
Ensure brevity in your answer.  -11.48. In the year 2003, what is the difference between the Emissions(in percent) of Low income and Emissions(in percent) of Portugal?
Your response must be concise. 45.08. In the year 2003, what is the difference between the Emissions(in percent) in Cuba and Emissions(in percent) in Estonia?
Your answer should be very brief. -76.49. In the year 2003, what is the difference between the Emissions(in percent) of Cuba and Emissions(in percent) of Portugal?
Your answer should be very brief. -19.93. In the year 2003, what is the difference between the Emissions(in percent) in Estonia and Emissions(in percent) in Portugal?
Provide a succinct answer. 56.56. In the year 2004, what is the difference between the Emissions(in percent) of Low income and Emissions(in percent) of Cuba?
Your answer should be very brief. 64.63. In the year 2004, what is the difference between the Emissions(in percent) in Low income and Emissions(in percent) in Estonia?
Your response must be concise. -11.17. In the year 2004, what is the difference between the Emissions(in percent) in Low income and Emissions(in percent) in Portugal?
Provide a succinct answer. 44.64. In the year 2004, what is the difference between the Emissions(in percent) of Cuba and Emissions(in percent) of Estonia?
Your answer should be very brief. -75.8. In the year 2004, what is the difference between the Emissions(in percent) in Cuba and Emissions(in percent) in Portugal?
Keep it short and to the point. -19.99. In the year 2004, what is the difference between the Emissions(in percent) in Estonia and Emissions(in percent) in Portugal?
Your response must be concise. 55.81. In the year 2005, what is the difference between the Emissions(in percent) of Low income and Emissions(in percent) of Cuba?
Offer a very short reply. 65.15. In the year 2005, what is the difference between the Emissions(in percent) in Low income and Emissions(in percent) in Estonia?
Your answer should be compact. -9.77. In the year 2005, what is the difference between the Emissions(in percent) in Low income and Emissions(in percent) in Portugal?
Provide a short and direct response. 45.89. In the year 2005, what is the difference between the Emissions(in percent) of Cuba and Emissions(in percent) of Estonia?
Provide a short and direct response. -74.92. In the year 2005, what is the difference between the Emissions(in percent) of Cuba and Emissions(in percent) of Portugal?
Your answer should be very brief. -19.26. In the year 2005, what is the difference between the Emissions(in percent) of Estonia and Emissions(in percent) of Portugal?
Provide a short and direct response. 55.66. In the year 2006, what is the difference between the Emissions(in percent) in Low income and Emissions(in percent) in Cuba?
Your answer should be compact. 64.24. In the year 2006, what is the difference between the Emissions(in percent) of Low income and Emissions(in percent) of Estonia?
Your answer should be very brief. -9.85. In the year 2006, what is the difference between the Emissions(in percent) in Low income and Emissions(in percent) in Portugal?
Make the answer very short. 43.29. In the year 2006, what is the difference between the Emissions(in percent) in Cuba and Emissions(in percent) in Estonia?
Keep it short and to the point. -74.09. In the year 2006, what is the difference between the Emissions(in percent) of Cuba and Emissions(in percent) of Portugal?
Offer a very short reply. -20.95. In the year 2006, what is the difference between the Emissions(in percent) in Estonia and Emissions(in percent) in Portugal?
Provide a succinct answer. 53.14. In the year 2007, what is the difference between the Emissions(in percent) in Low income and Emissions(in percent) in Cuba?
Make the answer very short. 58.29. In the year 2007, what is the difference between the Emissions(in percent) in Low income and Emissions(in percent) in Estonia?
Give a very brief answer. -19.19. In the year 2007, what is the difference between the Emissions(in percent) in Low income and Emissions(in percent) in Portugal?
Offer a very short reply. 40.6. In the year 2007, what is the difference between the Emissions(in percent) of Cuba and Emissions(in percent) of Estonia?
Your response must be concise. -77.48. In the year 2007, what is the difference between the Emissions(in percent) of Cuba and Emissions(in percent) of Portugal?
Keep it short and to the point. -17.7. In the year 2007, what is the difference between the Emissions(in percent) of Estonia and Emissions(in percent) of Portugal?
Offer a terse response. 59.79. In the year 2008, what is the difference between the Emissions(in percent) in Low income and Emissions(in percent) in Cuba?
Your answer should be compact. 58.07. In the year 2008, what is the difference between the Emissions(in percent) in Low income and Emissions(in percent) in Estonia?
Give a very brief answer. -19.16. In the year 2008, what is the difference between the Emissions(in percent) in Low income and Emissions(in percent) in Portugal?
Your answer should be compact. 40.86. In the year 2008, what is the difference between the Emissions(in percent) of Cuba and Emissions(in percent) of Estonia?
Provide a succinct answer. -77.23. In the year 2008, what is the difference between the Emissions(in percent) in Cuba and Emissions(in percent) in Portugal?
Ensure brevity in your answer.  -17.21. In the year 2008, what is the difference between the Emissions(in percent) of Estonia and Emissions(in percent) of Portugal?
Keep it short and to the point. 60.01. In the year 2009, what is the difference between the Emissions(in percent) in Low income and Emissions(in percent) in Cuba?
Offer a terse response. 56.06. In the year 2009, what is the difference between the Emissions(in percent) of Low income and Emissions(in percent) of Estonia?
Give a very brief answer. -25.39. In the year 2009, what is the difference between the Emissions(in percent) in Low income and Emissions(in percent) in Portugal?
Your answer should be compact. 36.68. In the year 2009, what is the difference between the Emissions(in percent) in Cuba and Emissions(in percent) in Estonia?
Make the answer very short. -81.45. In the year 2009, what is the difference between the Emissions(in percent) of Cuba and Emissions(in percent) of Portugal?
Ensure brevity in your answer.  -19.39. In the year 2009, what is the difference between the Emissions(in percent) in Estonia and Emissions(in percent) in Portugal?
Your response must be concise. 62.06. What is the ratio of the Emissions(in percent) of Low income in 2002 to that in 2003?
Make the answer very short. 1.02. What is the ratio of the Emissions(in percent) in Cuba in 2002 to that in 2003?
Your answer should be very brief. 0.69. What is the ratio of the Emissions(in percent) in Estonia in 2002 to that in 2003?
Ensure brevity in your answer.  0.98. What is the ratio of the Emissions(in percent) in Low income in 2002 to that in 2004?
Make the answer very short. 1.02. What is the ratio of the Emissions(in percent) in Cuba in 2002 to that in 2004?
Provide a short and direct response. 0.65. What is the ratio of the Emissions(in percent) in Portugal in 2002 to that in 2004?
Provide a succinct answer. 0.97. What is the ratio of the Emissions(in percent) in Low income in 2002 to that in 2005?
Offer a very short reply. 1.02. What is the ratio of the Emissions(in percent) of Cuba in 2002 to that in 2005?
Provide a succinct answer. 0.9. What is the ratio of the Emissions(in percent) in Estonia in 2002 to that in 2005?
Your answer should be compact. 1. What is the ratio of the Emissions(in percent) of Portugal in 2002 to that in 2005?
Offer a very short reply. 1.01. What is the ratio of the Emissions(in percent) in Low income in 2002 to that in 2006?
Offer a very short reply. 1.03. What is the ratio of the Emissions(in percent) in Cuba in 2002 to that in 2006?
Provide a short and direct response. 2.85. What is the ratio of the Emissions(in percent) of Estonia in 2002 to that in 2006?
Keep it short and to the point. 1.02. What is the ratio of the Emissions(in percent) of Low income in 2002 to that in 2007?
Your answer should be very brief. 1.14. What is the ratio of the Emissions(in percent) in Cuba in 2002 to that in 2007?
Ensure brevity in your answer.  0.98. What is the ratio of the Emissions(in percent) in Estonia in 2002 to that in 2007?
Ensure brevity in your answer.  0.97. What is the ratio of the Emissions(in percent) in Portugal in 2002 to that in 2007?
Offer a very short reply. 1.1. What is the ratio of the Emissions(in percent) of Low income in 2002 to that in 2008?
Your response must be concise. 1.14. What is the ratio of the Emissions(in percent) in Cuba in 2002 to that in 2008?
Make the answer very short. 0.89. What is the ratio of the Emissions(in percent) in Estonia in 2002 to that in 2008?
Offer a very short reply. 0.97. What is the ratio of the Emissions(in percent) in Portugal in 2002 to that in 2008?
Your answer should be compact. 1.13. What is the ratio of the Emissions(in percent) of Low income in 2002 to that in 2009?
Provide a succinct answer. 1.18. What is the ratio of the Emissions(in percent) in Cuba in 2002 to that in 2009?
Offer a terse response. 0.91. What is the ratio of the Emissions(in percent) in Estonia in 2002 to that in 2009?
Ensure brevity in your answer.  0.92. What is the ratio of the Emissions(in percent) of Portugal in 2002 to that in 2009?
Provide a short and direct response. 1. What is the ratio of the Emissions(in percent) of Low income in 2003 to that in 2004?
Your answer should be compact. 1.01. What is the ratio of the Emissions(in percent) in Cuba in 2003 to that in 2004?
Keep it short and to the point. 0.95. What is the ratio of the Emissions(in percent) of Estonia in 2003 to that in 2004?
Give a very brief answer. 1.01. What is the ratio of the Emissions(in percent) of Portugal in 2003 to that in 2004?
Give a very brief answer. 1. What is the ratio of the Emissions(in percent) in Cuba in 2003 to that in 2005?
Give a very brief answer. 1.31. What is the ratio of the Emissions(in percent) in Estonia in 2003 to that in 2005?
Keep it short and to the point. 1.02. What is the ratio of the Emissions(in percent) in Portugal in 2003 to that in 2005?
Make the answer very short. 1.04. What is the ratio of the Emissions(in percent) in Low income in 2003 to that in 2006?
Make the answer very short. 1.02. What is the ratio of the Emissions(in percent) of Cuba in 2003 to that in 2006?
Provide a short and direct response. 4.15. What is the ratio of the Emissions(in percent) in Estonia in 2003 to that in 2006?
Your answer should be very brief. 1.04. What is the ratio of the Emissions(in percent) in Portugal in 2003 to that in 2006?
Ensure brevity in your answer.  0.97. What is the ratio of the Emissions(in percent) of Low income in 2003 to that in 2007?
Ensure brevity in your answer.  1.12. What is the ratio of the Emissions(in percent) of Cuba in 2003 to that in 2007?
Your answer should be very brief. 1.42. What is the ratio of the Emissions(in percent) in Estonia in 2003 to that in 2007?
Provide a succinct answer. 0.99. What is the ratio of the Emissions(in percent) in Portugal in 2003 to that in 2007?
Give a very brief answer. 1.13. What is the ratio of the Emissions(in percent) of Low income in 2003 to that in 2008?
Make the answer very short. 1.12. What is the ratio of the Emissions(in percent) in Cuba in 2003 to that in 2008?
Make the answer very short. 1.29. What is the ratio of the Emissions(in percent) of Estonia in 2003 to that in 2008?
Offer a very short reply. 0.99. What is the ratio of the Emissions(in percent) in Portugal in 2003 to that in 2008?
Your answer should be very brief. 1.16. What is the ratio of the Emissions(in percent) of Low income in 2003 to that in 2009?
Ensure brevity in your answer.  1.16. What is the ratio of the Emissions(in percent) in Cuba in 2003 to that in 2009?
Keep it short and to the point. 1.32. What is the ratio of the Emissions(in percent) in Estonia in 2003 to that in 2009?
Your answer should be very brief. 0.94. What is the ratio of the Emissions(in percent) of Portugal in 2003 to that in 2009?
Your response must be concise. 1.03. What is the ratio of the Emissions(in percent) in Low income in 2004 to that in 2005?
Give a very brief answer. 0.99. What is the ratio of the Emissions(in percent) of Cuba in 2004 to that in 2005?
Keep it short and to the point. 1.39. What is the ratio of the Emissions(in percent) of Estonia in 2004 to that in 2005?
Offer a very short reply. 1.01. What is the ratio of the Emissions(in percent) in Portugal in 2004 to that in 2005?
Keep it short and to the point. 1.04. What is the ratio of the Emissions(in percent) in Low income in 2004 to that in 2006?
Your answer should be very brief. 1.01. What is the ratio of the Emissions(in percent) in Cuba in 2004 to that in 2006?
Give a very brief answer. 4.38. What is the ratio of the Emissions(in percent) in Estonia in 2004 to that in 2006?
Offer a very short reply. 1.03. What is the ratio of the Emissions(in percent) in Portugal in 2004 to that in 2006?
Provide a succinct answer. 0.97. What is the ratio of the Emissions(in percent) in Low income in 2004 to that in 2007?
Ensure brevity in your answer.  1.11. What is the ratio of the Emissions(in percent) in Cuba in 2004 to that in 2007?
Offer a terse response. 1.5. What is the ratio of the Emissions(in percent) in Estonia in 2004 to that in 2007?
Your answer should be compact. 0.98. What is the ratio of the Emissions(in percent) of Portugal in 2004 to that in 2007?
Offer a terse response. 1.13. What is the ratio of the Emissions(in percent) in Low income in 2004 to that in 2008?
Offer a terse response. 1.11. What is the ratio of the Emissions(in percent) in Cuba in 2004 to that in 2008?
Give a very brief answer. 1.36. What is the ratio of the Emissions(in percent) in Estonia in 2004 to that in 2008?
Your answer should be very brief. 0.98. What is the ratio of the Emissions(in percent) of Portugal in 2004 to that in 2008?
Your answer should be very brief. 1.16. What is the ratio of the Emissions(in percent) in Low income in 2004 to that in 2009?
Give a very brief answer. 1.15. What is the ratio of the Emissions(in percent) of Cuba in 2004 to that in 2009?
Provide a succinct answer. 1.39. What is the ratio of the Emissions(in percent) in Estonia in 2004 to that in 2009?
Offer a terse response. 0.93. What is the ratio of the Emissions(in percent) in Portugal in 2004 to that in 2009?
Keep it short and to the point. 1.04. What is the ratio of the Emissions(in percent) of Low income in 2005 to that in 2006?
Give a very brief answer. 1.02. What is the ratio of the Emissions(in percent) of Cuba in 2005 to that in 2006?
Give a very brief answer. 3.16. What is the ratio of the Emissions(in percent) in Portugal in 2005 to that in 2006?
Make the answer very short. 0.93. What is the ratio of the Emissions(in percent) of Low income in 2005 to that in 2007?
Provide a short and direct response. 1.12. What is the ratio of the Emissions(in percent) in Cuba in 2005 to that in 2007?
Make the answer very short. 1.08. What is the ratio of the Emissions(in percent) in Estonia in 2005 to that in 2007?
Give a very brief answer. 0.97. What is the ratio of the Emissions(in percent) of Portugal in 2005 to that in 2007?
Give a very brief answer. 1.09. What is the ratio of the Emissions(in percent) in Low income in 2005 to that in 2008?
Provide a short and direct response. 1.12. What is the ratio of the Emissions(in percent) of Cuba in 2005 to that in 2008?
Give a very brief answer. 0.98. What is the ratio of the Emissions(in percent) in Estonia in 2005 to that in 2008?
Give a very brief answer. 0.97. What is the ratio of the Emissions(in percent) in Portugal in 2005 to that in 2008?
Make the answer very short. 1.12. What is the ratio of the Emissions(in percent) of Low income in 2005 to that in 2009?
Keep it short and to the point. 1.16. What is the ratio of the Emissions(in percent) in Cuba in 2005 to that in 2009?
Your answer should be compact. 1.01. What is the ratio of the Emissions(in percent) of Estonia in 2005 to that in 2009?
Offer a very short reply. 0.92. What is the ratio of the Emissions(in percent) of Low income in 2006 to that in 2007?
Ensure brevity in your answer.  1.1. What is the ratio of the Emissions(in percent) in Cuba in 2006 to that in 2007?
Offer a very short reply. 0.34. What is the ratio of the Emissions(in percent) of Estonia in 2006 to that in 2007?
Your response must be concise. 0.95. What is the ratio of the Emissions(in percent) in Portugal in 2006 to that in 2007?
Make the answer very short. 1.17. What is the ratio of the Emissions(in percent) in Low income in 2006 to that in 2008?
Provide a short and direct response. 1.1. What is the ratio of the Emissions(in percent) of Cuba in 2006 to that in 2008?
Your answer should be very brief. 0.31. What is the ratio of the Emissions(in percent) in Estonia in 2006 to that in 2008?
Keep it short and to the point. 0.96. What is the ratio of the Emissions(in percent) in Portugal in 2006 to that in 2008?
Make the answer very short. 1.2. What is the ratio of the Emissions(in percent) in Low income in 2006 to that in 2009?
Offer a terse response. 1.14. What is the ratio of the Emissions(in percent) of Cuba in 2006 to that in 2009?
Provide a short and direct response. 0.32. What is the ratio of the Emissions(in percent) in Estonia in 2006 to that in 2009?
Offer a terse response. 0.91. What is the ratio of the Emissions(in percent) in Portugal in 2006 to that in 2009?
Provide a succinct answer. 1.07. What is the ratio of the Emissions(in percent) in Cuba in 2007 to that in 2008?
Provide a succinct answer. 0.91. What is the ratio of the Emissions(in percent) of Portugal in 2007 to that in 2008?
Your answer should be compact. 1.03. What is the ratio of the Emissions(in percent) in Low income in 2007 to that in 2009?
Give a very brief answer. 1.04. What is the ratio of the Emissions(in percent) of Cuba in 2007 to that in 2009?
Your answer should be compact. 0.93. What is the ratio of the Emissions(in percent) in Estonia in 2007 to that in 2009?
Make the answer very short. 0.95. What is the ratio of the Emissions(in percent) of Portugal in 2007 to that in 2009?
Offer a very short reply. 0.91. What is the ratio of the Emissions(in percent) in Low income in 2008 to that in 2009?
Your response must be concise. 1.04. What is the ratio of the Emissions(in percent) in Estonia in 2008 to that in 2009?
Provide a succinct answer. 0.95. What is the ratio of the Emissions(in percent) in Portugal in 2008 to that in 2009?
Make the answer very short. 0.89. What is the difference between the highest and the second highest Emissions(in percent) of Low income?
Ensure brevity in your answer.  1.14. What is the difference between the highest and the second highest Emissions(in percent) of Cuba?
Provide a succinct answer. 0.02. What is the difference between the highest and the second highest Emissions(in percent) of Estonia?
Offer a very short reply. 3.99. What is the difference between the highest and the second highest Emissions(in percent) in Portugal?
Offer a very short reply. 0.65. What is the difference between the highest and the lowest Emissions(in percent) in Low income?
Keep it short and to the point. 10.23. What is the difference between the highest and the lowest Emissions(in percent) in Cuba?
Keep it short and to the point. 0.32. What is the difference between the highest and the lowest Emissions(in percent) in Estonia?
Your answer should be very brief. 7.57. What is the difference between the highest and the lowest Emissions(in percent) in Portugal?
Give a very brief answer. 3.53. 